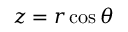<formula> <loc_0><loc_0><loc_500><loc_500>z = r \cos \theta</formula> 